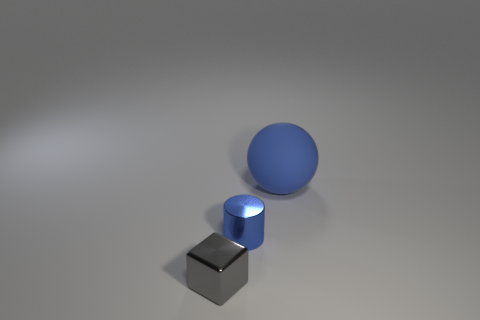Is there anything else that is the same material as the big thing?
Give a very brief answer. No. What number of big cylinders have the same color as the rubber sphere?
Ensure brevity in your answer.  0. There is a tiny metal thing that is to the right of the thing that is in front of the blue cylinder; what is its shape?
Your response must be concise. Cylinder. How many things have the same material as the cylinder?
Offer a terse response. 1. There is a tiny thing behind the gray thing; what is its material?
Make the answer very short. Metal. What shape is the small object behind the small object that is to the left of the tiny metallic object right of the small gray shiny object?
Your response must be concise. Cylinder. There is a metal thing in front of the cylinder; is its color the same as the matte object that is to the right of the tiny blue metal object?
Give a very brief answer. No. Is the number of blue shiny cylinders on the right side of the gray metal block less than the number of tiny blue metallic things that are right of the large object?
Offer a terse response. No. Is there anything else that has the same shape as the matte thing?
Provide a short and direct response. No. There is a tiny gray object; is it the same shape as the matte thing that is right of the tiny metal cube?
Ensure brevity in your answer.  No. 